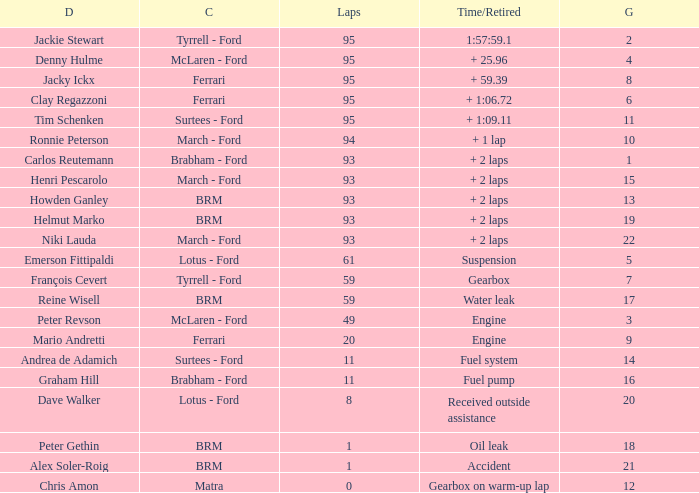What is the lowest grid with matra as constructor? 12.0. 